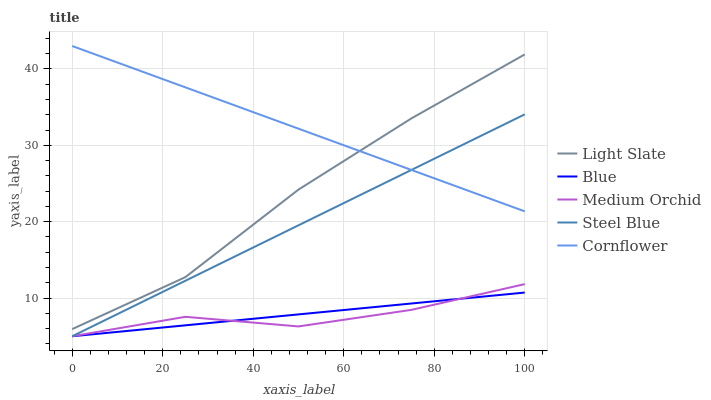Does Medium Orchid have the minimum area under the curve?
Answer yes or no. Yes. Does Cornflower have the maximum area under the curve?
Answer yes or no. Yes. Does Blue have the minimum area under the curve?
Answer yes or no. No. Does Blue have the maximum area under the curve?
Answer yes or no. No. Is Blue the smoothest?
Answer yes or no. Yes. Is Medium Orchid the roughest?
Answer yes or no. Yes. Is Medium Orchid the smoothest?
Answer yes or no. No. Is Blue the roughest?
Answer yes or no. No. Does Blue have the lowest value?
Answer yes or no. Yes. Does Cornflower have the lowest value?
Answer yes or no. No. Does Cornflower have the highest value?
Answer yes or no. Yes. Does Medium Orchid have the highest value?
Answer yes or no. No. Is Medium Orchid less than Cornflower?
Answer yes or no. Yes. Is Cornflower greater than Blue?
Answer yes or no. Yes. Does Light Slate intersect Cornflower?
Answer yes or no. Yes. Is Light Slate less than Cornflower?
Answer yes or no. No. Is Light Slate greater than Cornflower?
Answer yes or no. No. Does Medium Orchid intersect Cornflower?
Answer yes or no. No. 